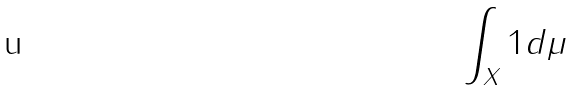<formula> <loc_0><loc_0><loc_500><loc_500>\int _ { X } 1 d \mu</formula> 